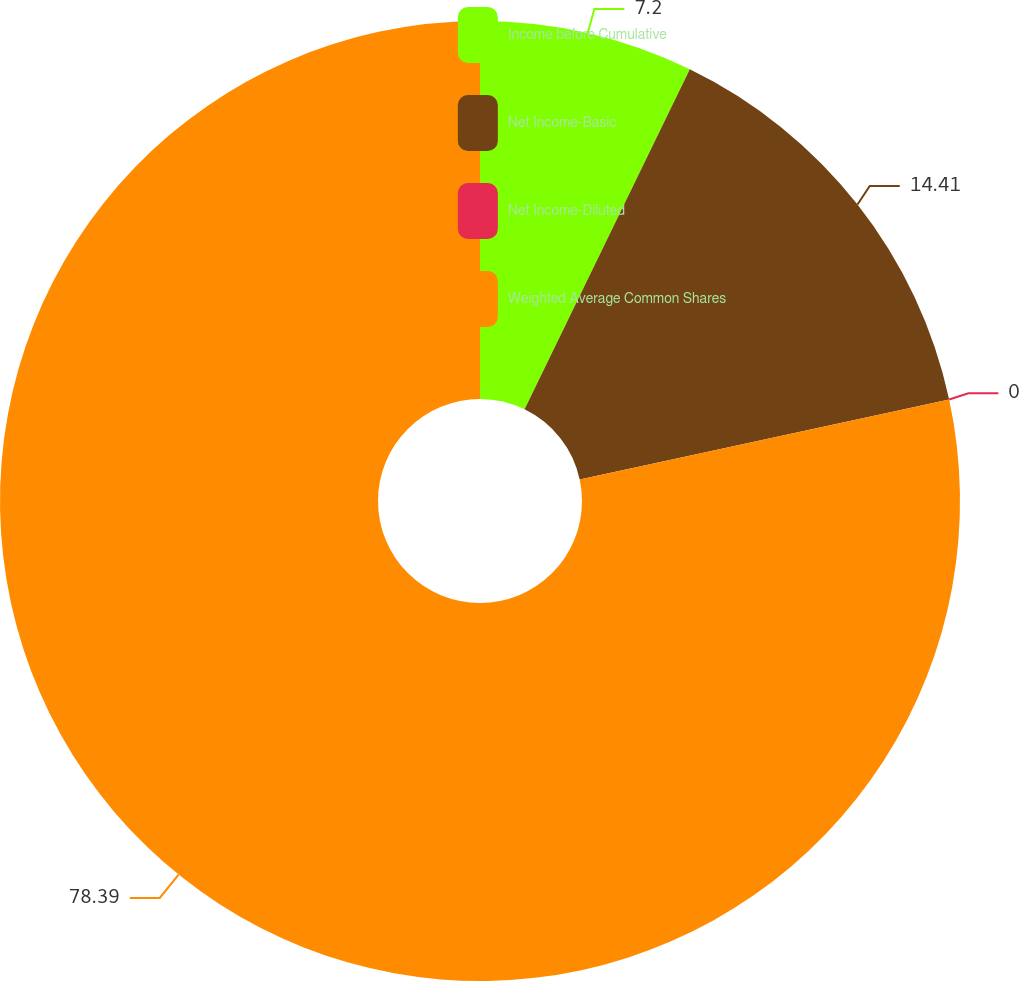<chart> <loc_0><loc_0><loc_500><loc_500><pie_chart><fcel>Income before Cumulative<fcel>Net Income-Basic<fcel>Net Income-Diluted<fcel>Weighted Average Common Shares<nl><fcel>7.2%<fcel>14.41%<fcel>0.0%<fcel>78.39%<nl></chart> 